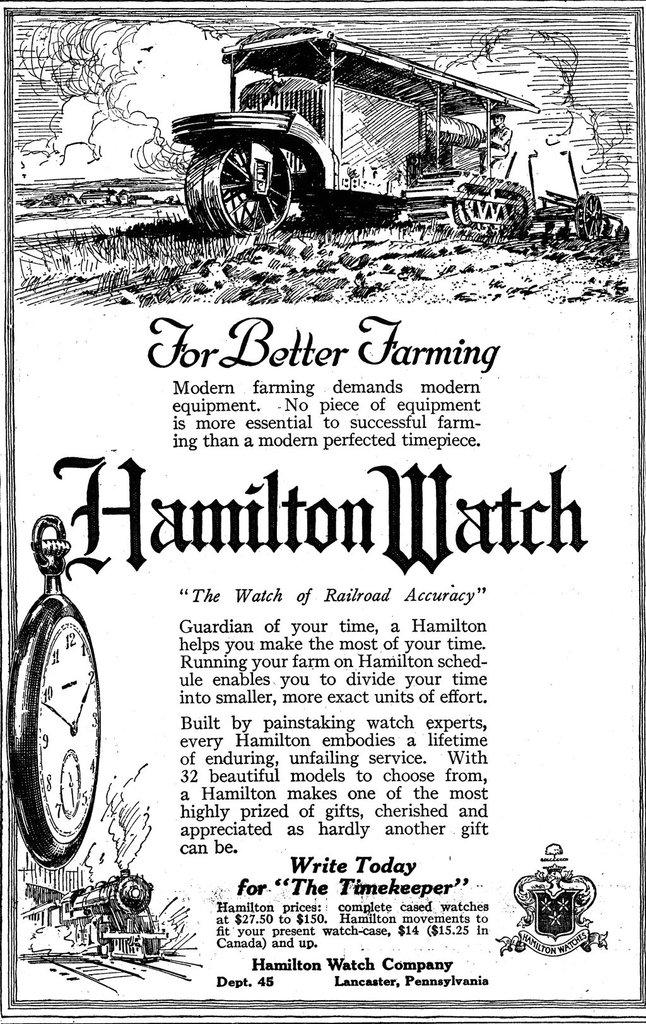What is depicted on the printed paper in the image? There is a picture of a vehicle and a picture of a train on the paper. What else can be seen on the printed paper? There is text on the printed paper. What object is present in the image that can be used to tell time? There is a clock in the image. Can you describe the type of paper in the image? The paper is printed with images and text. How many boys are holding wine glasses in the image? There are no boys or wine glasses present in the image. What type of wealth is displayed in the image? There is no wealth displayed in the image; it features a printed paper with images and text, a clock, and no other objects or people. 